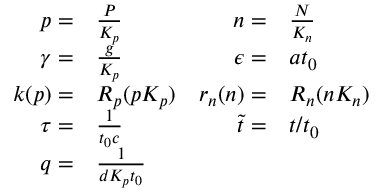Convert formula to latex. <formula><loc_0><loc_0><loc_500><loc_500>\begin{array} { r l r l } { p = } & \frac { P } { K _ { p } } } & { n = } & \frac { N } { K _ { n } } } \\ { \gamma = } & \frac { g } { K _ { p } } } & { \epsilon = } & a t _ { 0 } } \\ { k ( p ) = } & R _ { p } ( p K _ { p } ) } & { r _ { n } ( n ) = } & R _ { n } ( n K _ { n } ) } \\ { \tau = } & \frac { 1 } { t _ { 0 } c } } & { \tilde { t } = } & t / t _ { 0 } } \\ { q = } & \frac { 1 } { d K _ { p } t _ { 0 } } } \end{array}</formula> 